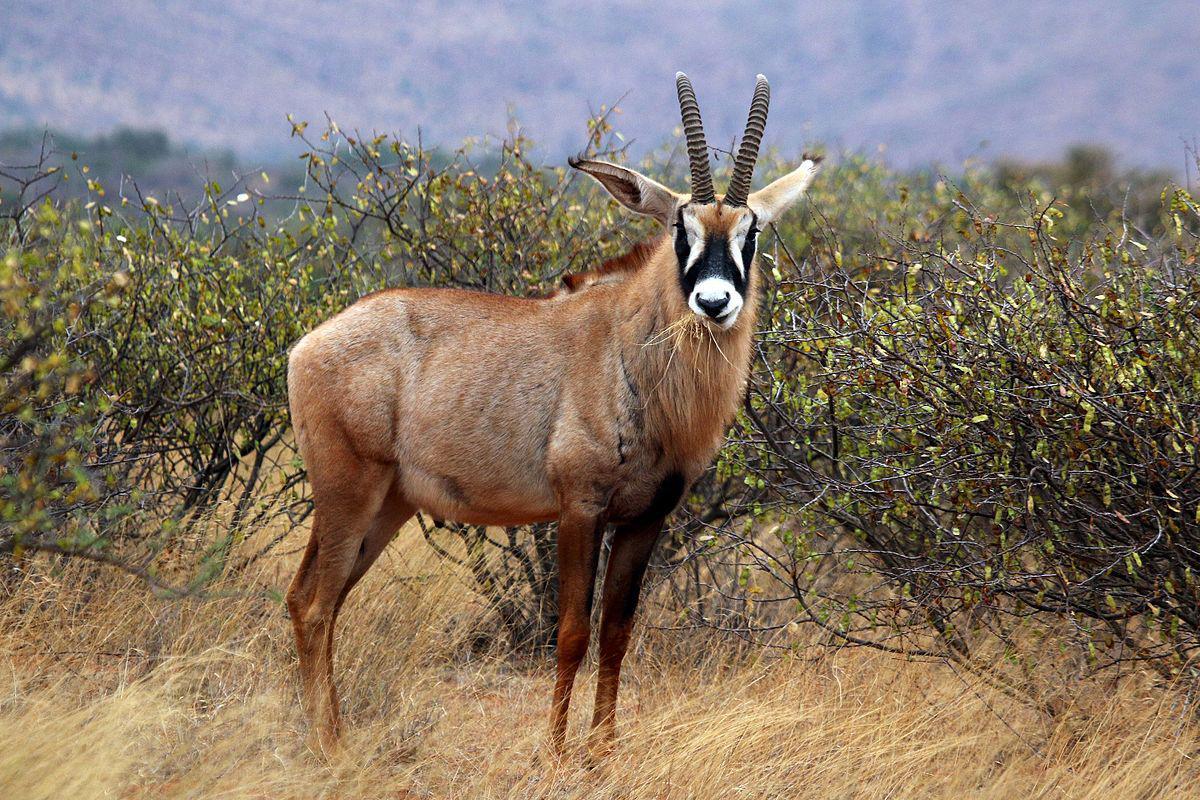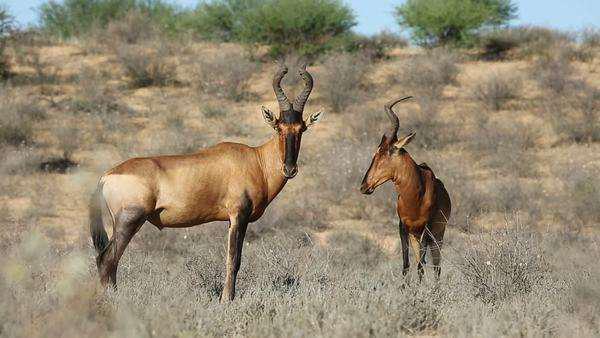The first image is the image on the left, the second image is the image on the right. For the images displayed, is the sentence "There are three animals." factually correct? Answer yes or no. Yes. 